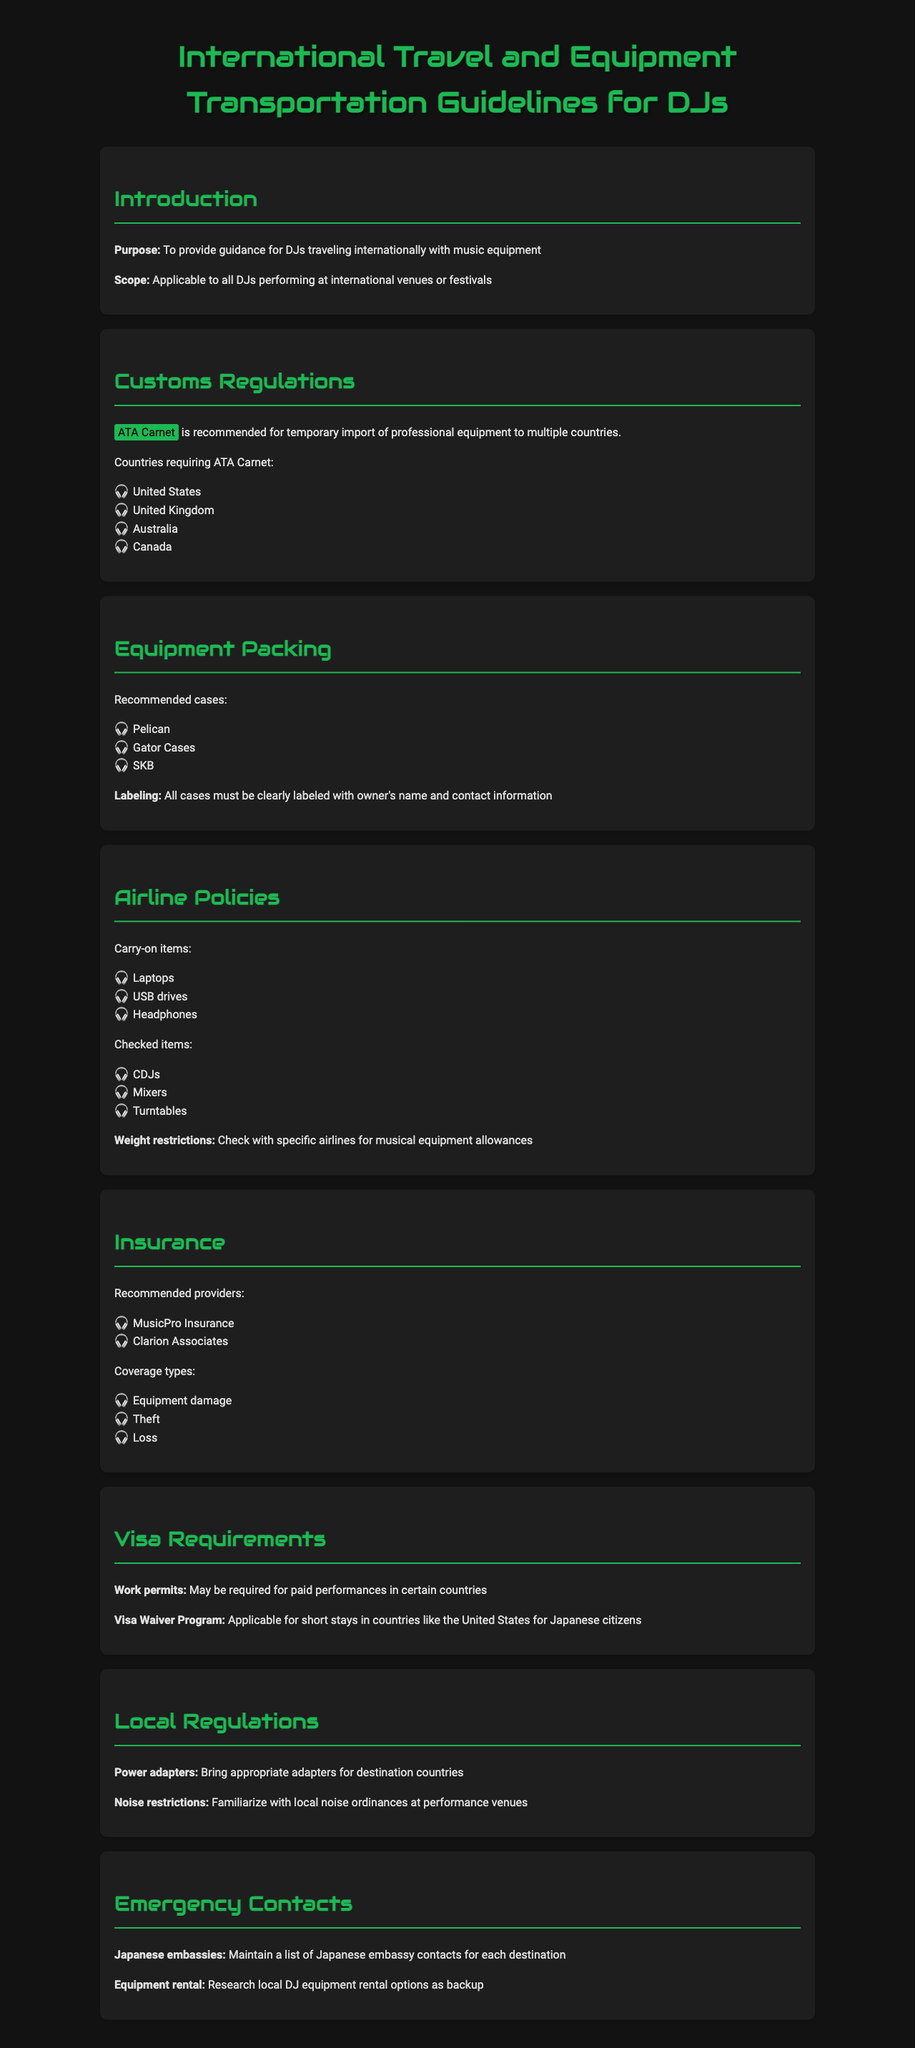What is the recommended document for temporary import? The recommended document for temporary import of professional equipment is the ATA Carnet, as mentioned in the Customs Regulations section.
Answer: ATA Carnet Which countries require the ATA Carnet? The document lists specific countries where the ATA Carnet is required: United States, United Kingdom, Australia, Canada.
Answer: United States, United Kingdom, Australia, Canada What type of cases are recommended for packing equipment? The document recommends specific case brands for packing equipment: Pelican, Gator Cases, SKB.
Answer: Pelican, Gator Cases, SKB What items are classified as carry-on for airlines? The document specifies certain items allowed as carry-on, including laptops, USB drives, and headphones.
Answer: Laptops, USB drives, Headphones What may be required for paid performances in certain countries? The document states that work permits may be required for paid performances, as indicated in the Visa Requirements section.
Answer: Work permits What should DJs bring for power compatibility? The guideline mentions that DJs should bring appropriate adapters for destination countries.
Answer: Power adapters Which insurance provider focuses on covering equipment loss? The document recommends specific providers, including MusicPro Insurance and Clarion Associates, for covering equipment loss in the context of insurance.
Answer: MusicPro Insurance What must be labeled on equipment cases? According to the Equipment Packing section, all cases must be clearly labeled with the owner's name and contact information.
Answer: Owner's name and contact information What is the primary purpose of this document? The document's primary purpose, as stated in the Introduction section, is to provide guidance for DJs traveling internationally with music equipment.
Answer: Guidance for DJs traveling internationally 